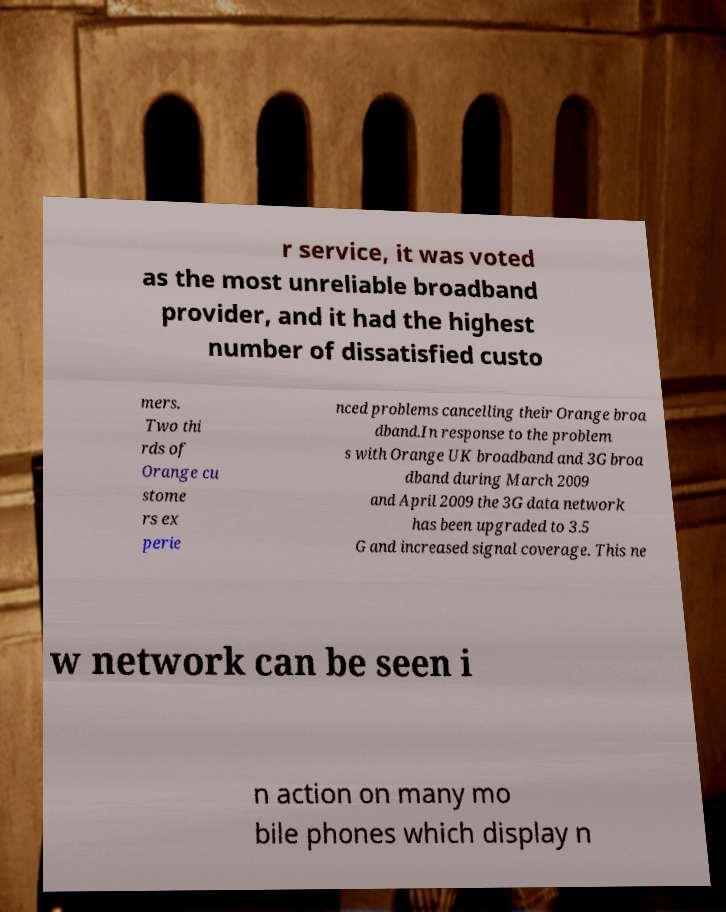Can you read and provide the text displayed in the image?This photo seems to have some interesting text. Can you extract and type it out for me? r service, it was voted as the most unreliable broadband provider, and it had the highest number of dissatisfied custo mers. Two thi rds of Orange cu stome rs ex perie nced problems cancelling their Orange broa dband.In response to the problem s with Orange UK broadband and 3G broa dband during March 2009 and April 2009 the 3G data network has been upgraded to 3.5 G and increased signal coverage. This ne w network can be seen i n action on many mo bile phones which display n 